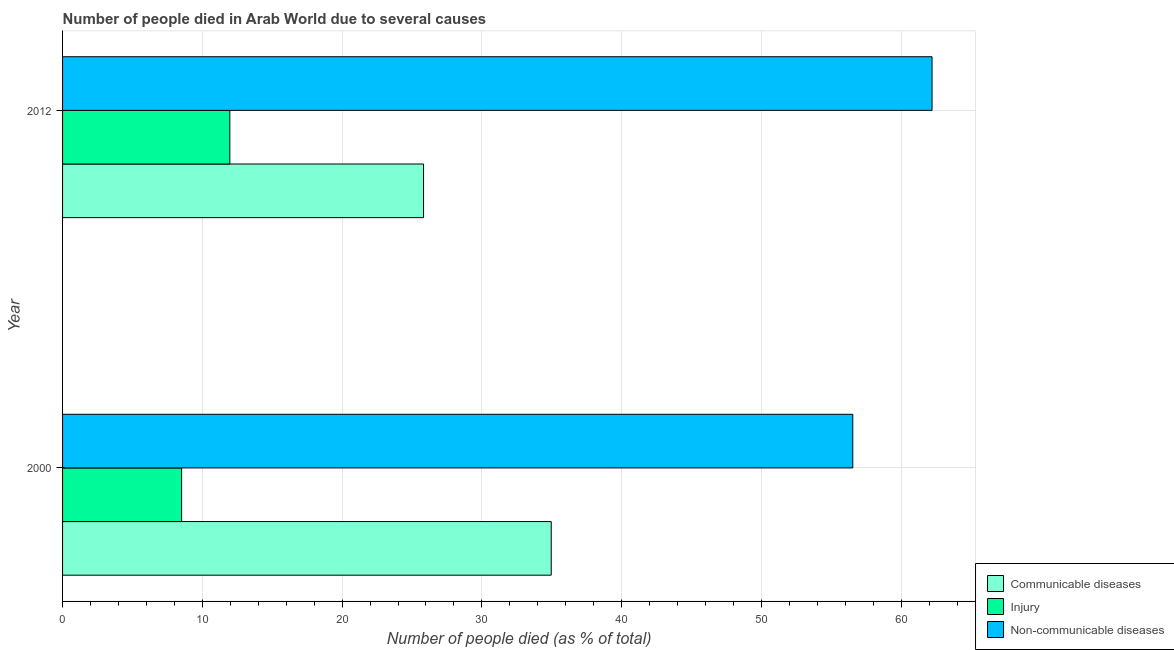How many different coloured bars are there?
Keep it short and to the point. 3. How many groups of bars are there?
Ensure brevity in your answer.  2. Are the number of bars per tick equal to the number of legend labels?
Provide a succinct answer. Yes. Are the number of bars on each tick of the Y-axis equal?
Your answer should be very brief. Yes. How many bars are there on the 1st tick from the bottom?
Give a very brief answer. 3. What is the label of the 1st group of bars from the top?
Offer a terse response. 2012. In how many cases, is the number of bars for a given year not equal to the number of legend labels?
Provide a succinct answer. 0. What is the number of people who dies of non-communicable diseases in 2000?
Your answer should be very brief. 56.54. Across all years, what is the maximum number of people who died of injury?
Provide a succinct answer. 11.97. Across all years, what is the minimum number of people who dies of non-communicable diseases?
Make the answer very short. 56.54. What is the total number of people who died of communicable diseases in the graph?
Your response must be concise. 60.79. What is the difference between the number of people who died of injury in 2000 and that in 2012?
Ensure brevity in your answer.  -3.45. What is the difference between the number of people who dies of non-communicable diseases in 2000 and the number of people who died of communicable diseases in 2012?
Provide a succinct answer. 30.71. What is the average number of people who died of injury per year?
Make the answer very short. 10.24. In the year 2012, what is the difference between the number of people who died of communicable diseases and number of people who dies of non-communicable diseases?
Provide a succinct answer. -36.38. What is the ratio of the number of people who died of communicable diseases in 2000 to that in 2012?
Make the answer very short. 1.35. Is the number of people who died of communicable diseases in 2000 less than that in 2012?
Provide a succinct answer. No. Is the difference between the number of people who died of communicable diseases in 2000 and 2012 greater than the difference between the number of people who dies of non-communicable diseases in 2000 and 2012?
Ensure brevity in your answer.  Yes. In how many years, is the number of people who died of injury greater than the average number of people who died of injury taken over all years?
Make the answer very short. 1. What does the 3rd bar from the top in 2000 represents?
Provide a short and direct response. Communicable diseases. What does the 3rd bar from the bottom in 2012 represents?
Offer a terse response. Non-communicable diseases. Is it the case that in every year, the sum of the number of people who died of communicable diseases and number of people who died of injury is greater than the number of people who dies of non-communicable diseases?
Provide a succinct answer. No. How many years are there in the graph?
Your response must be concise. 2. How many legend labels are there?
Make the answer very short. 3. What is the title of the graph?
Give a very brief answer. Number of people died in Arab World due to several causes. Does "Ages 65 and above" appear as one of the legend labels in the graph?
Keep it short and to the point. No. What is the label or title of the X-axis?
Provide a short and direct response. Number of people died (as % of total). What is the label or title of the Y-axis?
Provide a succinct answer. Year. What is the Number of people died (as % of total) in Communicable diseases in 2000?
Your answer should be very brief. 34.96. What is the Number of people died (as % of total) of Injury in 2000?
Your answer should be compact. 8.52. What is the Number of people died (as % of total) in Non-communicable diseases in 2000?
Keep it short and to the point. 56.54. What is the Number of people died (as % of total) in Communicable diseases in 2012?
Offer a very short reply. 25.83. What is the Number of people died (as % of total) of Injury in 2012?
Your answer should be very brief. 11.97. What is the Number of people died (as % of total) in Non-communicable diseases in 2012?
Ensure brevity in your answer.  62.21. Across all years, what is the maximum Number of people died (as % of total) in Communicable diseases?
Keep it short and to the point. 34.96. Across all years, what is the maximum Number of people died (as % of total) in Injury?
Your answer should be compact. 11.97. Across all years, what is the maximum Number of people died (as % of total) in Non-communicable diseases?
Your answer should be very brief. 62.21. Across all years, what is the minimum Number of people died (as % of total) of Communicable diseases?
Your response must be concise. 25.83. Across all years, what is the minimum Number of people died (as % of total) in Injury?
Ensure brevity in your answer.  8.52. Across all years, what is the minimum Number of people died (as % of total) of Non-communicable diseases?
Your response must be concise. 56.54. What is the total Number of people died (as % of total) in Communicable diseases in the graph?
Your response must be concise. 60.79. What is the total Number of people died (as % of total) in Injury in the graph?
Provide a succinct answer. 20.49. What is the total Number of people died (as % of total) in Non-communicable diseases in the graph?
Give a very brief answer. 118.74. What is the difference between the Number of people died (as % of total) in Communicable diseases in 2000 and that in 2012?
Provide a succinct answer. 9.13. What is the difference between the Number of people died (as % of total) of Injury in 2000 and that in 2012?
Provide a short and direct response. -3.45. What is the difference between the Number of people died (as % of total) in Non-communicable diseases in 2000 and that in 2012?
Offer a very short reply. -5.67. What is the difference between the Number of people died (as % of total) of Communicable diseases in 2000 and the Number of people died (as % of total) of Injury in 2012?
Your response must be concise. 22.99. What is the difference between the Number of people died (as % of total) in Communicable diseases in 2000 and the Number of people died (as % of total) in Non-communicable diseases in 2012?
Keep it short and to the point. -27.25. What is the difference between the Number of people died (as % of total) in Injury in 2000 and the Number of people died (as % of total) in Non-communicable diseases in 2012?
Provide a succinct answer. -53.69. What is the average Number of people died (as % of total) in Communicable diseases per year?
Keep it short and to the point. 30.39. What is the average Number of people died (as % of total) of Injury per year?
Ensure brevity in your answer.  10.24. What is the average Number of people died (as % of total) of Non-communicable diseases per year?
Make the answer very short. 59.37. In the year 2000, what is the difference between the Number of people died (as % of total) of Communicable diseases and Number of people died (as % of total) of Injury?
Keep it short and to the point. 26.44. In the year 2000, what is the difference between the Number of people died (as % of total) of Communicable diseases and Number of people died (as % of total) of Non-communicable diseases?
Your response must be concise. -21.58. In the year 2000, what is the difference between the Number of people died (as % of total) in Injury and Number of people died (as % of total) in Non-communicable diseases?
Provide a short and direct response. -48.02. In the year 2012, what is the difference between the Number of people died (as % of total) in Communicable diseases and Number of people died (as % of total) in Injury?
Give a very brief answer. 13.86. In the year 2012, what is the difference between the Number of people died (as % of total) in Communicable diseases and Number of people died (as % of total) in Non-communicable diseases?
Your response must be concise. -36.38. In the year 2012, what is the difference between the Number of people died (as % of total) of Injury and Number of people died (as % of total) of Non-communicable diseases?
Your response must be concise. -50.24. What is the ratio of the Number of people died (as % of total) in Communicable diseases in 2000 to that in 2012?
Your answer should be very brief. 1.35. What is the ratio of the Number of people died (as % of total) in Injury in 2000 to that in 2012?
Your response must be concise. 0.71. What is the ratio of the Number of people died (as % of total) in Non-communicable diseases in 2000 to that in 2012?
Keep it short and to the point. 0.91. What is the difference between the highest and the second highest Number of people died (as % of total) of Communicable diseases?
Keep it short and to the point. 9.13. What is the difference between the highest and the second highest Number of people died (as % of total) in Injury?
Make the answer very short. 3.45. What is the difference between the highest and the second highest Number of people died (as % of total) of Non-communicable diseases?
Your answer should be very brief. 5.67. What is the difference between the highest and the lowest Number of people died (as % of total) in Communicable diseases?
Ensure brevity in your answer.  9.13. What is the difference between the highest and the lowest Number of people died (as % of total) in Injury?
Give a very brief answer. 3.45. What is the difference between the highest and the lowest Number of people died (as % of total) in Non-communicable diseases?
Keep it short and to the point. 5.67. 